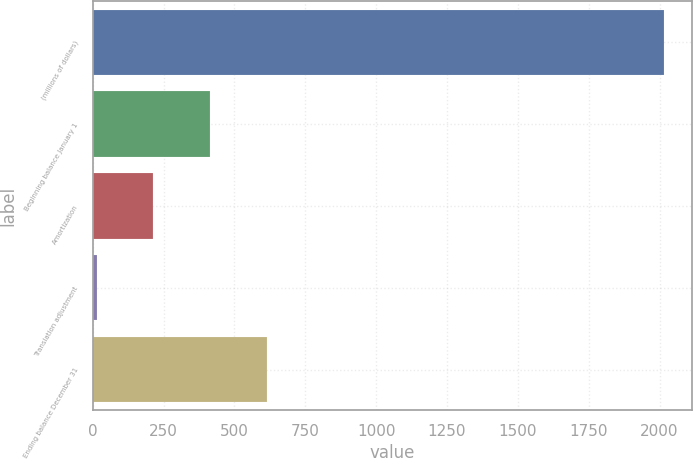Convert chart. <chart><loc_0><loc_0><loc_500><loc_500><bar_chart><fcel>(millions of dollars)<fcel>Beginning balance January 1<fcel>Amortization<fcel>Translation adjustment<fcel>Ending balance December 31<nl><fcel>2015<fcel>414.52<fcel>214.46<fcel>14.4<fcel>614.58<nl></chart> 